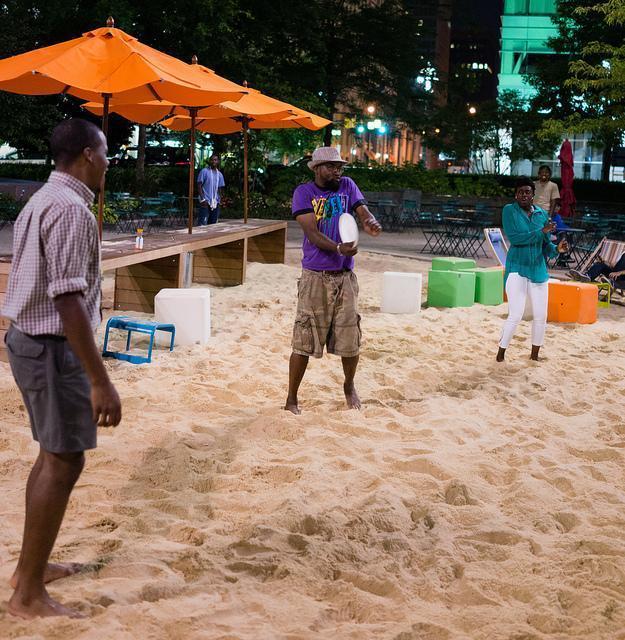How many humans are in the foreground of the picture?
Give a very brief answer. 3. How many people can you see?
Give a very brief answer. 3. How many umbrellas are there?
Give a very brief answer. 3. How many adult giraffe are seen?
Give a very brief answer. 0. 